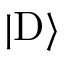<formula> <loc_0><loc_0><loc_500><loc_500>| D \rangle</formula> 